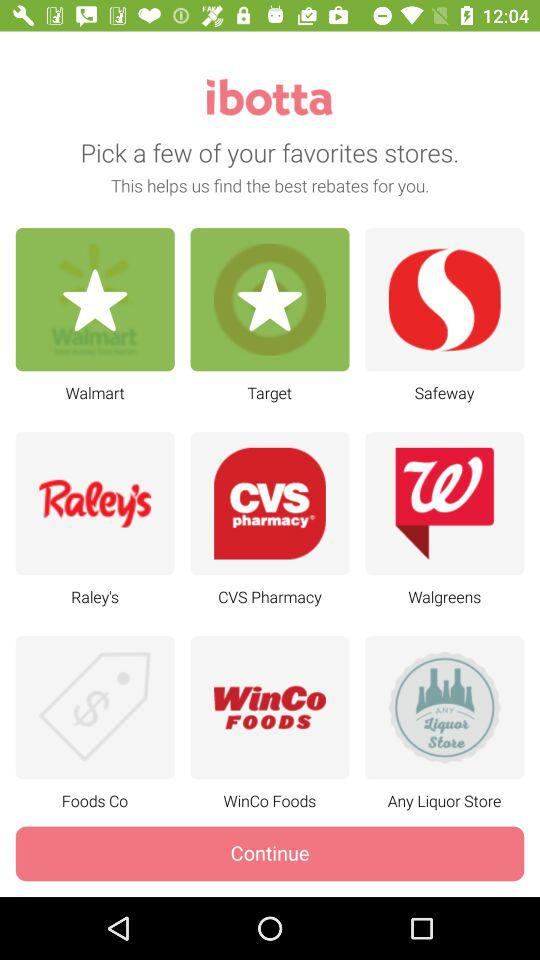What is the name of the application? The name of the application is "ibotta". 